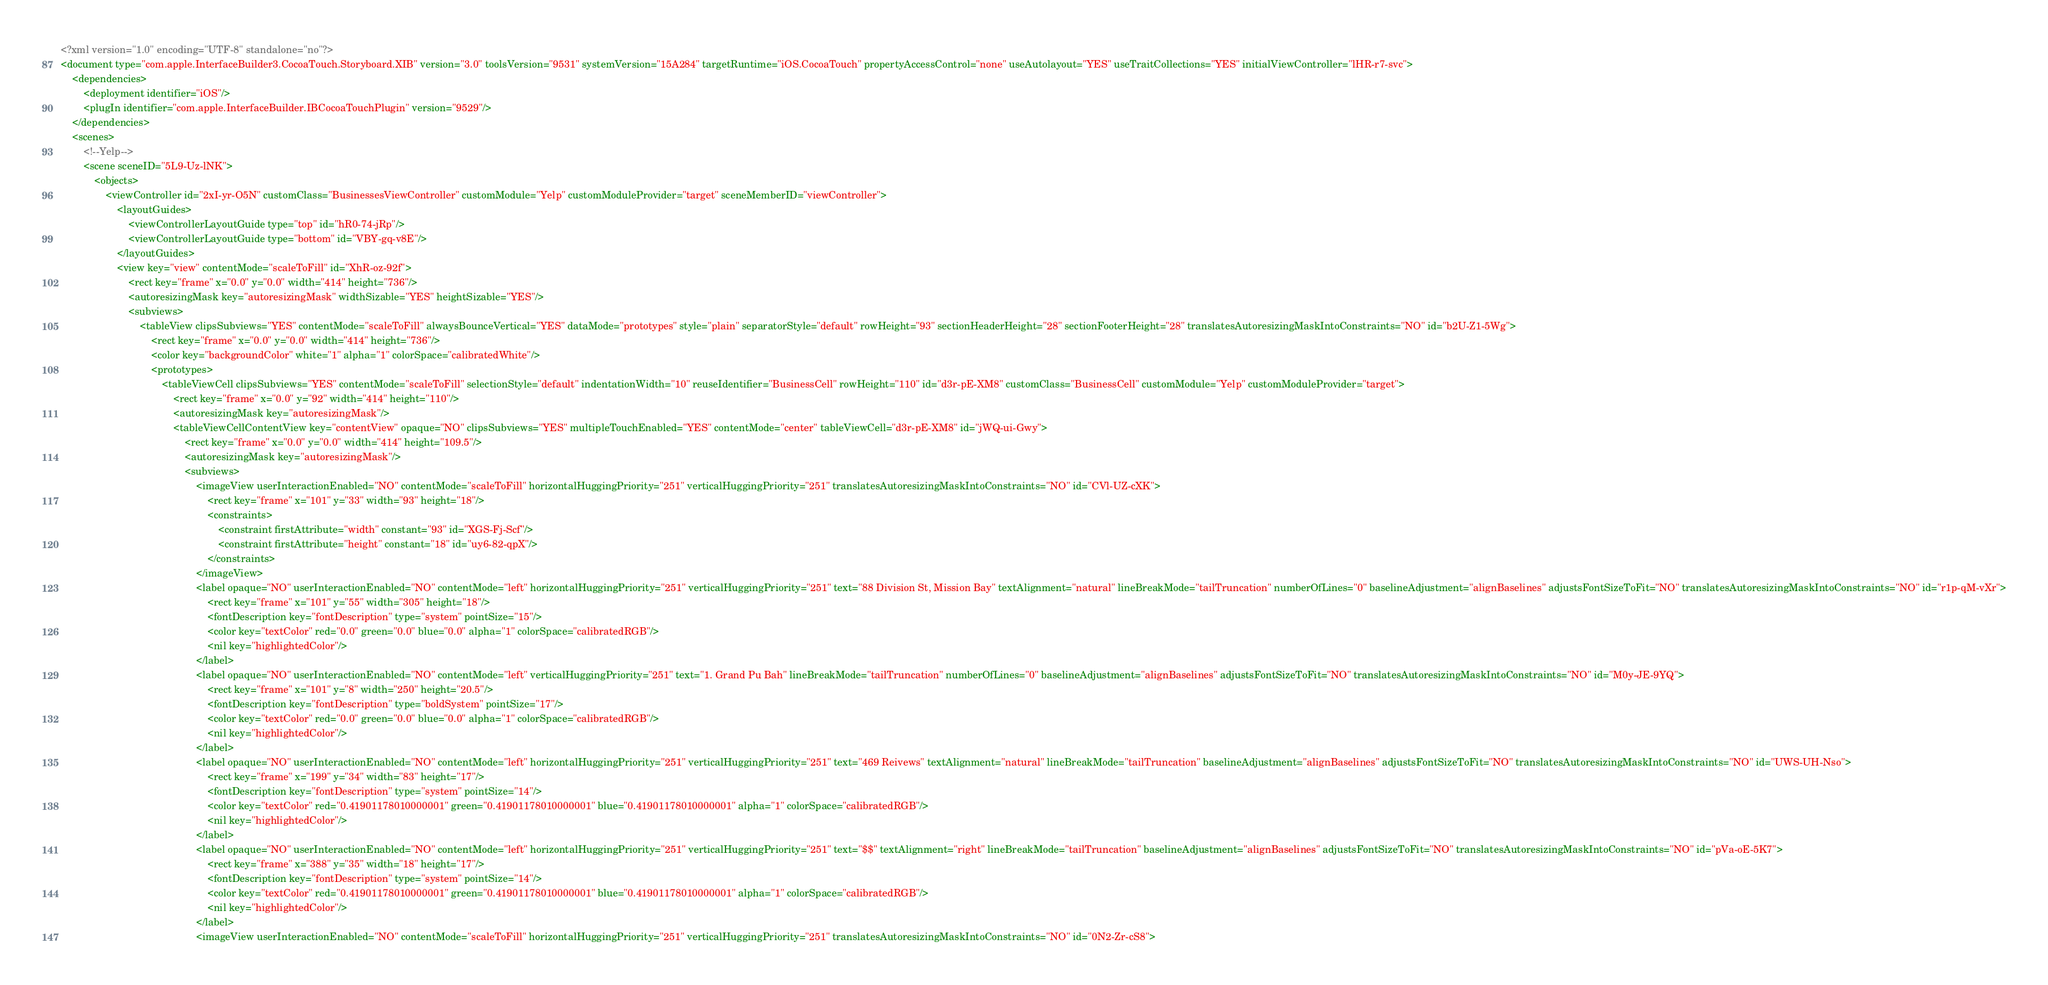<code> <loc_0><loc_0><loc_500><loc_500><_XML_><?xml version="1.0" encoding="UTF-8" standalone="no"?>
<document type="com.apple.InterfaceBuilder3.CocoaTouch.Storyboard.XIB" version="3.0" toolsVersion="9531" systemVersion="15A284" targetRuntime="iOS.CocoaTouch" propertyAccessControl="none" useAutolayout="YES" useTraitCollections="YES" initialViewController="lHR-r7-svc">
    <dependencies>
        <deployment identifier="iOS"/>
        <plugIn identifier="com.apple.InterfaceBuilder.IBCocoaTouchPlugin" version="9529"/>
    </dependencies>
    <scenes>
        <!--Yelp-->
        <scene sceneID="5L9-Uz-lNK">
            <objects>
                <viewController id="2xI-yr-O5N" customClass="BusinessesViewController" customModule="Yelp" customModuleProvider="target" sceneMemberID="viewController">
                    <layoutGuides>
                        <viewControllerLayoutGuide type="top" id="hR0-74-jRp"/>
                        <viewControllerLayoutGuide type="bottom" id="VBY-gq-v8E"/>
                    </layoutGuides>
                    <view key="view" contentMode="scaleToFill" id="XhR-oz-92f">
                        <rect key="frame" x="0.0" y="0.0" width="414" height="736"/>
                        <autoresizingMask key="autoresizingMask" widthSizable="YES" heightSizable="YES"/>
                        <subviews>
                            <tableView clipsSubviews="YES" contentMode="scaleToFill" alwaysBounceVertical="YES" dataMode="prototypes" style="plain" separatorStyle="default" rowHeight="93" sectionHeaderHeight="28" sectionFooterHeight="28" translatesAutoresizingMaskIntoConstraints="NO" id="b2U-Z1-5Wg">
                                <rect key="frame" x="0.0" y="0.0" width="414" height="736"/>
                                <color key="backgroundColor" white="1" alpha="1" colorSpace="calibratedWhite"/>
                                <prototypes>
                                    <tableViewCell clipsSubviews="YES" contentMode="scaleToFill" selectionStyle="default" indentationWidth="10" reuseIdentifier="BusinessCell" rowHeight="110" id="d3r-pE-XM8" customClass="BusinessCell" customModule="Yelp" customModuleProvider="target">
                                        <rect key="frame" x="0.0" y="92" width="414" height="110"/>
                                        <autoresizingMask key="autoresizingMask"/>
                                        <tableViewCellContentView key="contentView" opaque="NO" clipsSubviews="YES" multipleTouchEnabled="YES" contentMode="center" tableViewCell="d3r-pE-XM8" id="jWQ-ui-Gwy">
                                            <rect key="frame" x="0.0" y="0.0" width="414" height="109.5"/>
                                            <autoresizingMask key="autoresizingMask"/>
                                            <subviews>
                                                <imageView userInteractionEnabled="NO" contentMode="scaleToFill" horizontalHuggingPriority="251" verticalHuggingPriority="251" translatesAutoresizingMaskIntoConstraints="NO" id="CVl-UZ-cXK">
                                                    <rect key="frame" x="101" y="33" width="93" height="18"/>
                                                    <constraints>
                                                        <constraint firstAttribute="width" constant="93" id="XGS-Fj-Scf"/>
                                                        <constraint firstAttribute="height" constant="18" id="uy6-82-qpX"/>
                                                    </constraints>
                                                </imageView>
                                                <label opaque="NO" userInteractionEnabled="NO" contentMode="left" horizontalHuggingPriority="251" verticalHuggingPriority="251" text="88 Division St, Mission Bay" textAlignment="natural" lineBreakMode="tailTruncation" numberOfLines="0" baselineAdjustment="alignBaselines" adjustsFontSizeToFit="NO" translatesAutoresizingMaskIntoConstraints="NO" id="r1p-qM-vXr">
                                                    <rect key="frame" x="101" y="55" width="305" height="18"/>
                                                    <fontDescription key="fontDescription" type="system" pointSize="15"/>
                                                    <color key="textColor" red="0.0" green="0.0" blue="0.0" alpha="1" colorSpace="calibratedRGB"/>
                                                    <nil key="highlightedColor"/>
                                                </label>
                                                <label opaque="NO" userInteractionEnabled="NO" contentMode="left" verticalHuggingPriority="251" text="1. Grand Pu Bah" lineBreakMode="tailTruncation" numberOfLines="0" baselineAdjustment="alignBaselines" adjustsFontSizeToFit="NO" translatesAutoresizingMaskIntoConstraints="NO" id="M0y-JE-9YQ">
                                                    <rect key="frame" x="101" y="8" width="250" height="20.5"/>
                                                    <fontDescription key="fontDescription" type="boldSystem" pointSize="17"/>
                                                    <color key="textColor" red="0.0" green="0.0" blue="0.0" alpha="1" colorSpace="calibratedRGB"/>
                                                    <nil key="highlightedColor"/>
                                                </label>
                                                <label opaque="NO" userInteractionEnabled="NO" contentMode="left" horizontalHuggingPriority="251" verticalHuggingPriority="251" text="469 Reivews" textAlignment="natural" lineBreakMode="tailTruncation" baselineAdjustment="alignBaselines" adjustsFontSizeToFit="NO" translatesAutoresizingMaskIntoConstraints="NO" id="UWS-UH-Nso">
                                                    <rect key="frame" x="199" y="34" width="83" height="17"/>
                                                    <fontDescription key="fontDescription" type="system" pointSize="14"/>
                                                    <color key="textColor" red="0.41901178010000001" green="0.41901178010000001" blue="0.41901178010000001" alpha="1" colorSpace="calibratedRGB"/>
                                                    <nil key="highlightedColor"/>
                                                </label>
                                                <label opaque="NO" userInteractionEnabled="NO" contentMode="left" horizontalHuggingPriority="251" verticalHuggingPriority="251" text="$$" textAlignment="right" lineBreakMode="tailTruncation" baselineAdjustment="alignBaselines" adjustsFontSizeToFit="NO" translatesAutoresizingMaskIntoConstraints="NO" id="pVa-oE-5K7">
                                                    <rect key="frame" x="388" y="35" width="18" height="17"/>
                                                    <fontDescription key="fontDescription" type="system" pointSize="14"/>
                                                    <color key="textColor" red="0.41901178010000001" green="0.41901178010000001" blue="0.41901178010000001" alpha="1" colorSpace="calibratedRGB"/>
                                                    <nil key="highlightedColor"/>
                                                </label>
                                                <imageView userInteractionEnabled="NO" contentMode="scaleToFill" horizontalHuggingPriority="251" verticalHuggingPriority="251" translatesAutoresizingMaskIntoConstraints="NO" id="0N2-Zr-cS8"></code> 